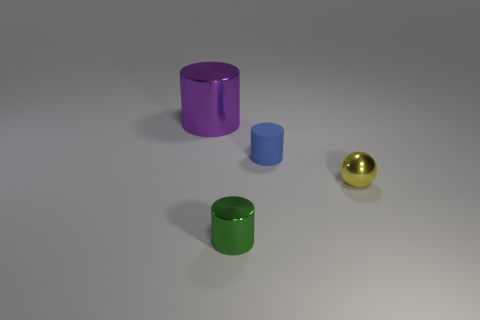Add 4 big brown shiny spheres. How many objects exist? 8 Subtract all cylinders. How many objects are left? 1 Add 2 small green cylinders. How many small green cylinders are left? 3 Add 3 big blue rubber cubes. How many big blue rubber cubes exist? 3 Subtract 0 green spheres. How many objects are left? 4 Subtract all green cubes. Subtract all big purple cylinders. How many objects are left? 3 